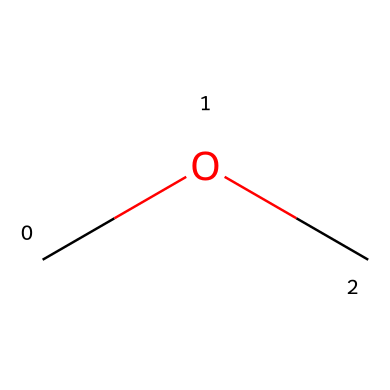What is the name of the chemical represented by the SMILES "COC"? The structure represented by "COC" indicates that there are two methyl groups attached to an oxygen atom, which is characteristic of dimethyl ether.
Answer: dimethyl ether How many carbon atoms are present in dimethyl ether? The SMILES notation "COC" has two "C" characters, indicating that there are two carbon atoms in the molecule.
Answer: two What is the total number of hydrogen atoms in dimethyl ether? Each methyl group (CH3) contributes three hydrogen atoms and since there are two carbon atoms, the total number of hydrogen atoms is six.
Answer: six What functional group is present in dimethyl ether? The presence of the oxygen atom connected between two carbon atoms indicates that the functional group is an ether, which is defined as R-O-R'.
Answer: ether Is dimethyl ether a primary, secondary, or tertiary ether? Dimethyl ether has two methyl groups as substituents, making it classified as a simple or primary ether due to its monoatomic structure with respect to the ether functional group.
Answer: primary What environmental benefit does dimethyl ether have as a propellant? Dimethyl ether has a low carbon footprint and produces fewer greenhouse gases compared to traditional propellants, making it an environmentally friendly option.
Answer: eco-friendly 